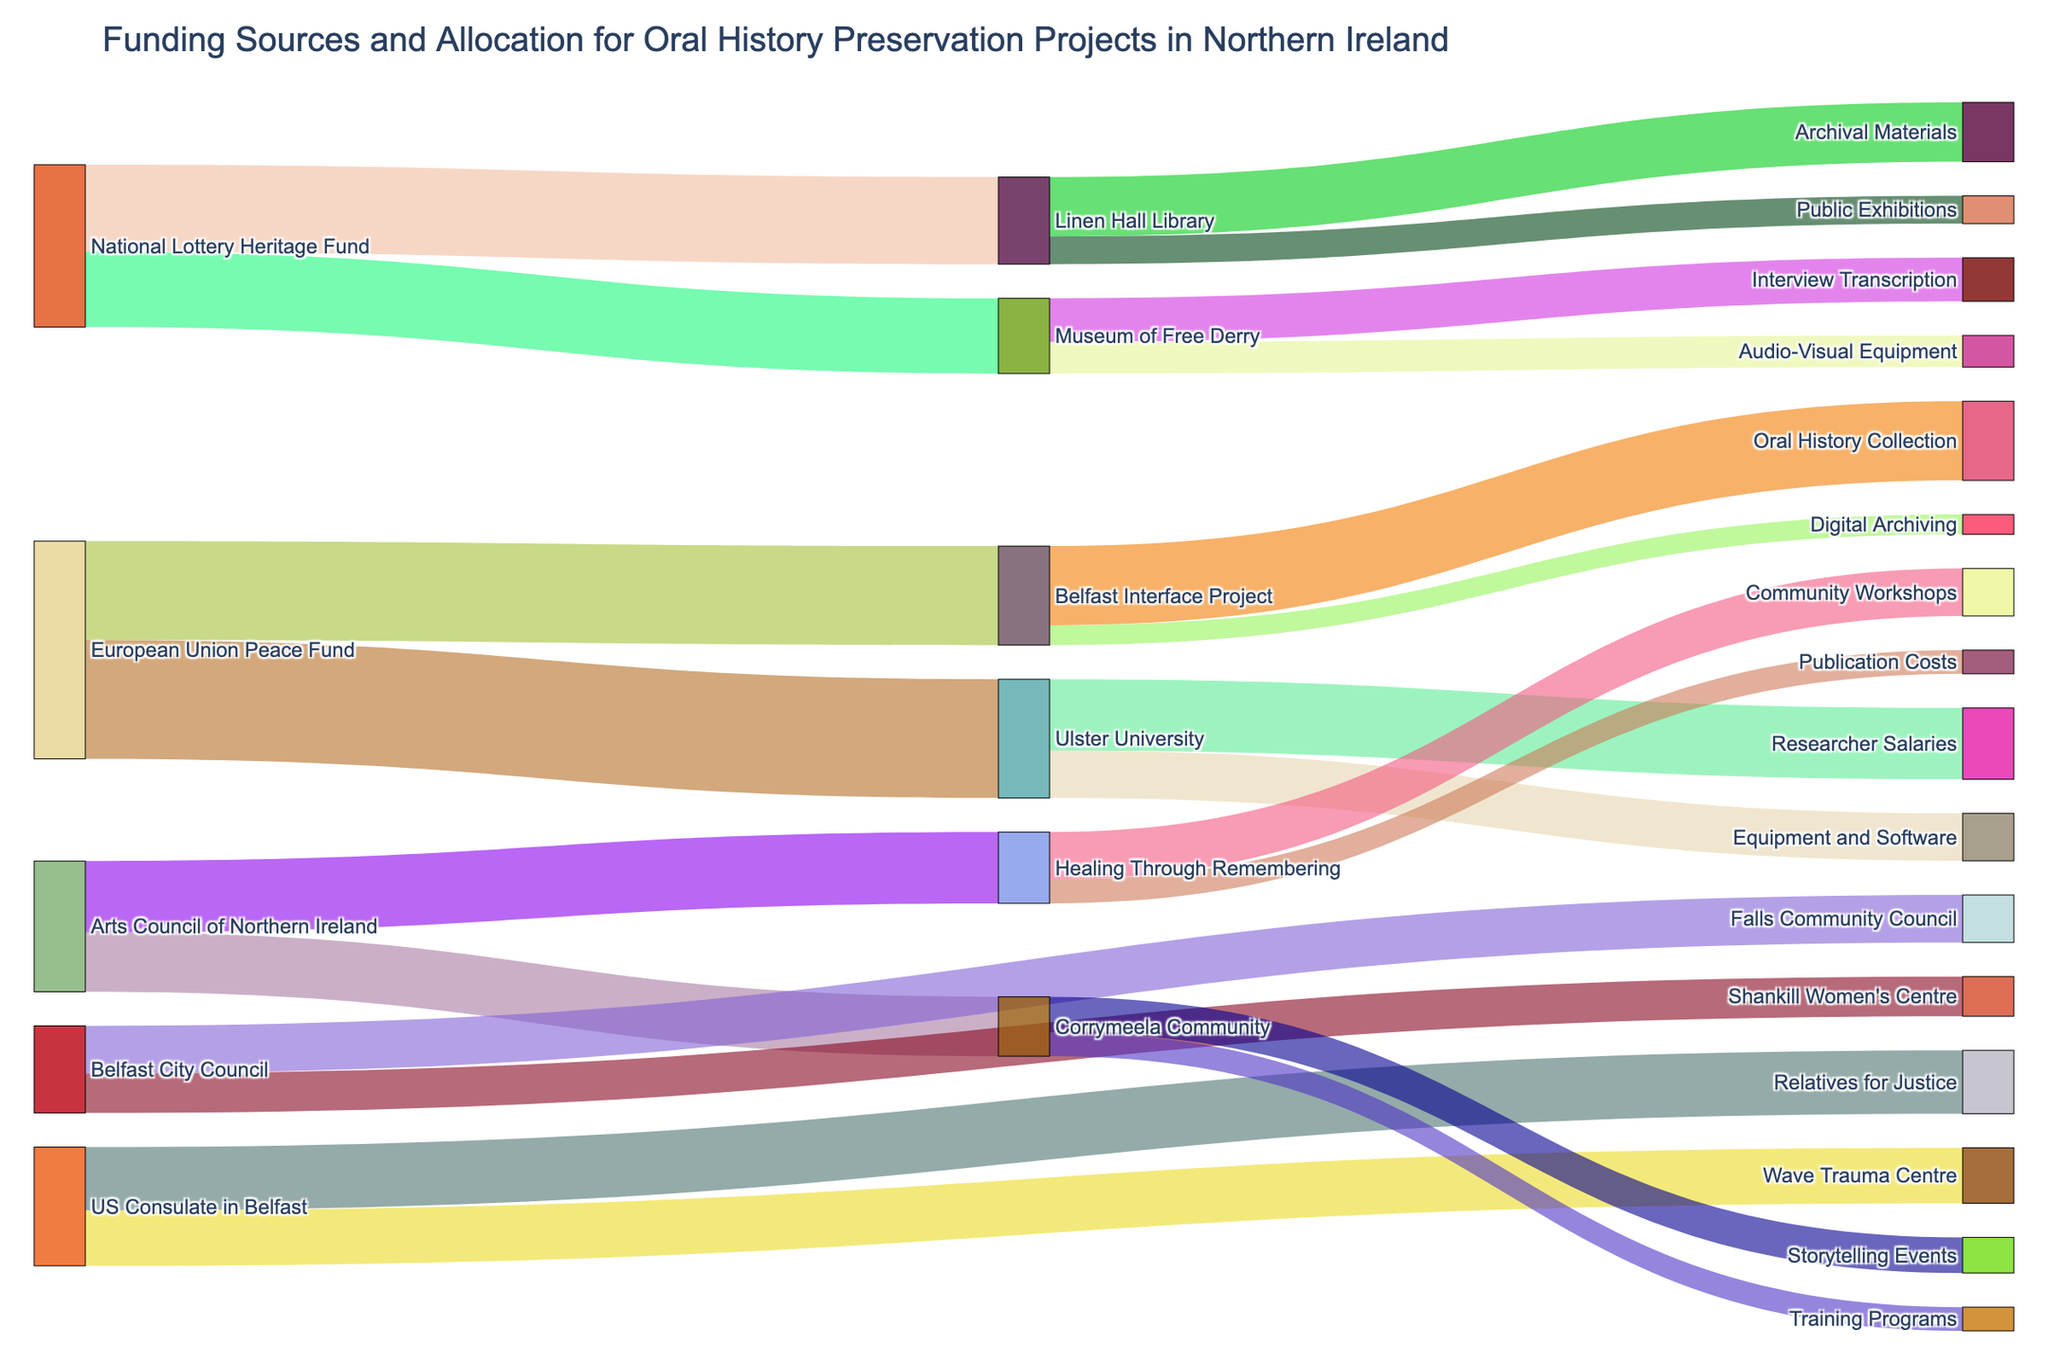What is the main title of the Sankey diagram? The title is typically displayed at the top of the figure and it summarizes the main theme of the visual representation. In this case, the title should mention the funding sources and allocation context.
Answer: Funding Sources and Allocation for Oral History Preservation Projects in Northern Ireland How much funding did the European Union Peace Fund allocate in total? By looking at the connections from the European Union Peace Fund node, identify all the target allocations and sum their values: Belfast Interface Project (250,000) and Ulster University (300,000).
Answer: 550,000 Which organization received the highest funding from the National Lottery Heritage Fund? Check the target connections from the National Lottery Heritage Fund and compare the values: Linen Hall Library (220,000) and Museum of Free Derry (190,000). Linen Hall Library received the higher amount.
Answer: Linen Hall Library Which projects received funding from the US Consulate in Belfast? Trace the connections from the US Consulate in Belfast to its targets to identify the projects: Relatives for Justice and Wave Trauma Centre.
Answer: Relatives for Justice, Wave Trauma Centre How much funding did the Belfast Interface Project allocate for Oral History Collection and Digital Archiving combined? Locate the Belfast Interface Project node and sum the values allocated to Oral History Collection (200,000) and Digital Archiving (50,000): 200,000 + 50,000.
Answer: 250,000 Which organization provided funding for the publication costs in the project? Follow the connections in the diagram to see which node leads to "Publication Costs." Healing Through Remembering is connected to Publication Costs.
Answer: Healing Through Remembering Among the allocations from Ulster University, which project received the least funding? Trace the allocations from Ulster University and compare the values: Researcher Salaries (180,000) and Equipment and Software (120,000). Equipment and Software received the least funding.
Answer: Equipment and Software Compare the funding amounts provided by Belfast City Council to Falls Community Council and Shankill Women's Centre. Which one received more? Look at the connections from Belfast City Council to its targets: Falls Community Council (120,000) and Shankill Women's Centre (100,000). Falls Community Council received more.
Answer: Falls Community Council What is the total funding allocated by the Arts Council of Northern Ireland? Sum the values allocated by the Arts Council of Northern Ireland to its targets: Healing Through Remembering (180,000) and Corrymeela Community (150,000): 180,000 + 150,000.
Answer: 330,000 Identify the project that received funding for both Archival Materials and Public Exhibitions. Trace the target that has connections to both Archival Materials and Public Exhibitions. Linen Hall Library received funding for both projects.
Answer: Linen Hall Library 